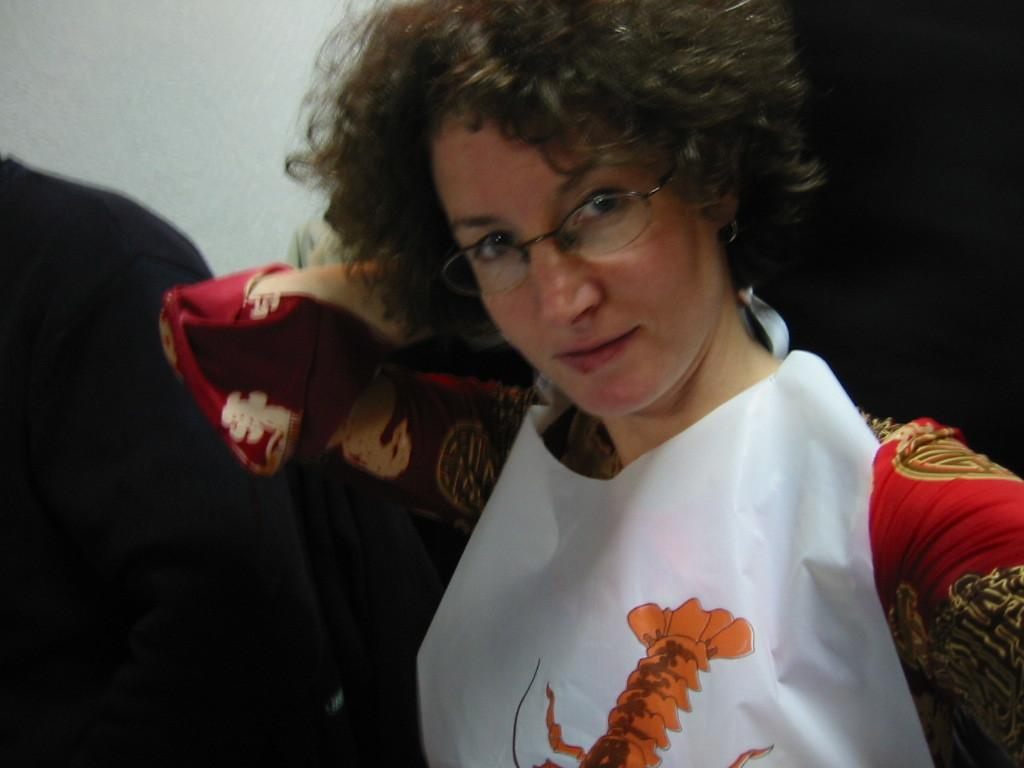Who is the main subject in the image? There is a lady in the image. What is the lady doing in the image? The lady is standing. What is the lady wearing in the image? The lady is wearing a white and red dress and glasses. Are there any other people in the image? Yes, there are other people in the image. What type of zipper can be seen on the lady's knee in the image? There is no zipper visible on the lady's knee in the image. What control does the lady have over the other people in the image? The image does not provide any information about the lady having control over the other people in the image. 